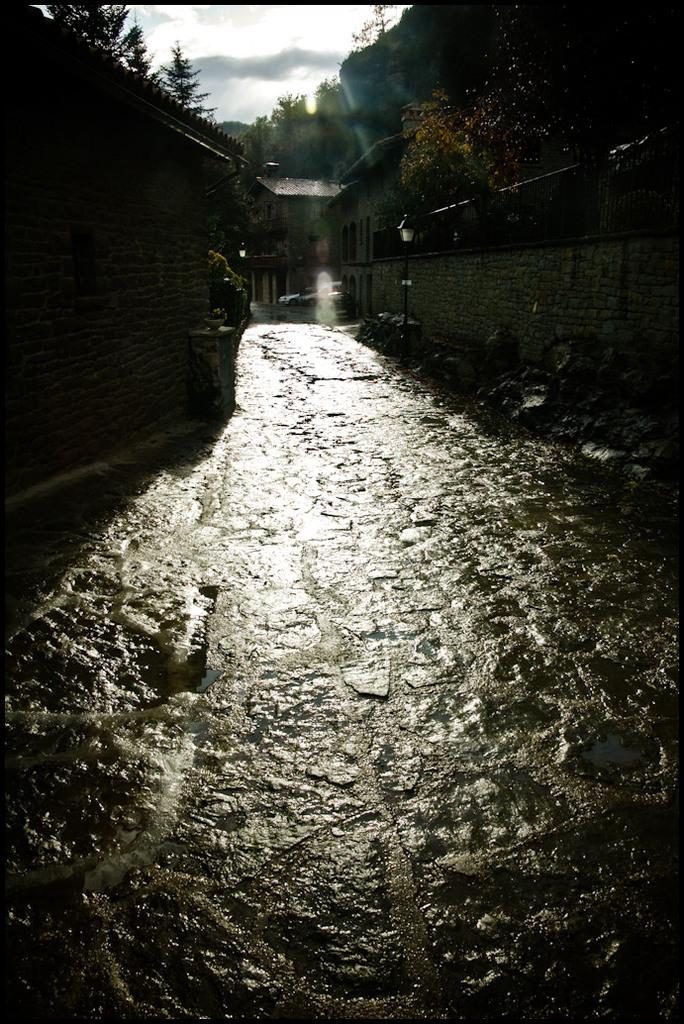Can you describe this image briefly? This is wet ground. Here we can see light poles and walls. Background we can see buildings and trees. Sky is cloudy. 